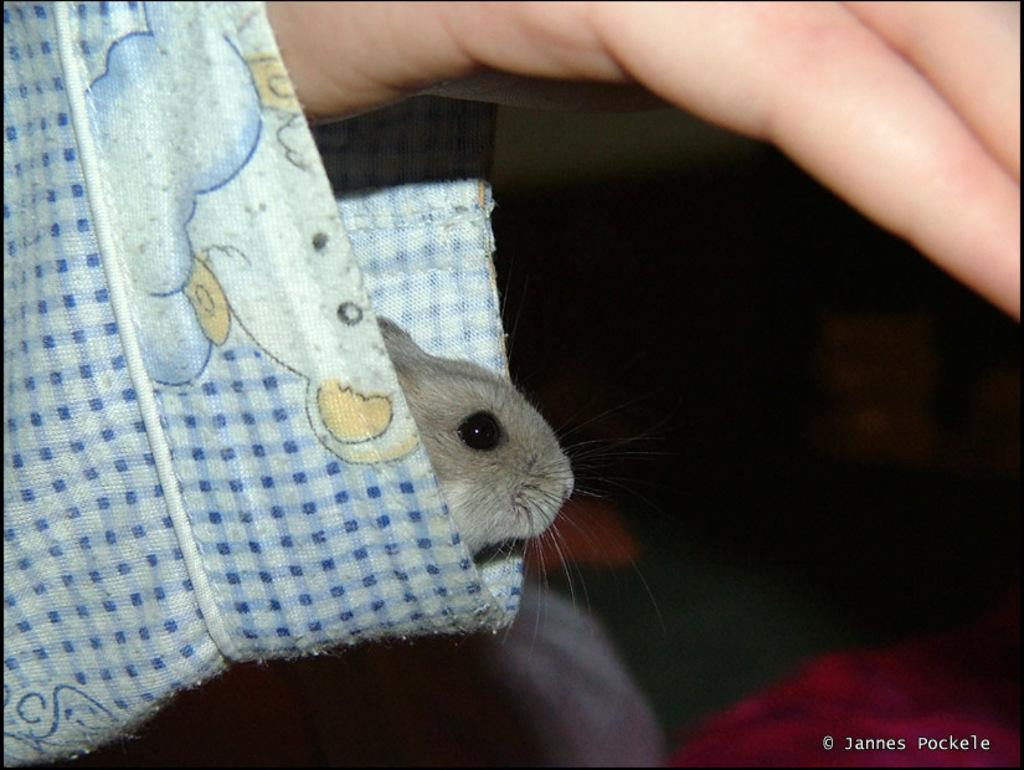What part of a person can be seen in the image? There is a person's hand in the image. What is inside the sleeve of the person's hand? A rat is present in the sleeve of the person's hand. Can you describe the background of the image? The background of the image is unclear. What else can be seen in the background of the image? There are objects visible in the background of the image. How does the person guide the rat using their hand in the image? There is no indication in the image that the person is guiding the rat; the rat is simply present in the sleeve of the person's hand. 